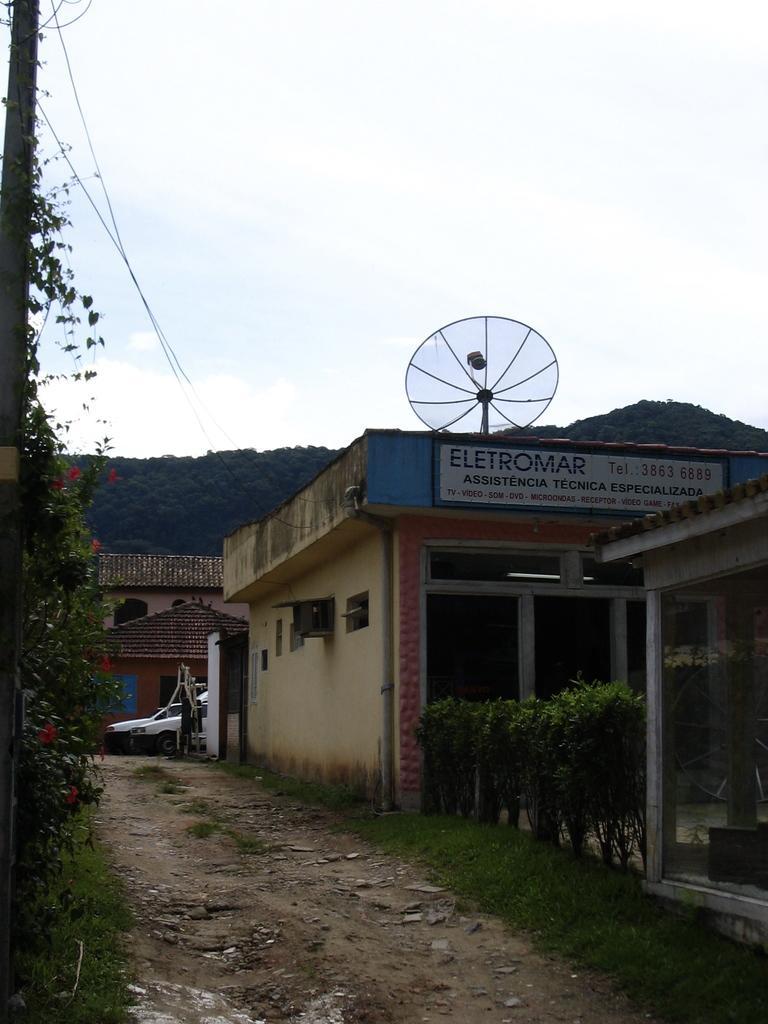In one or two sentences, can you explain what this image depicts? In this image we can see the pathway, grass, plants, houses, vehicles moving on the road, trees, wires and the sky in the background. 